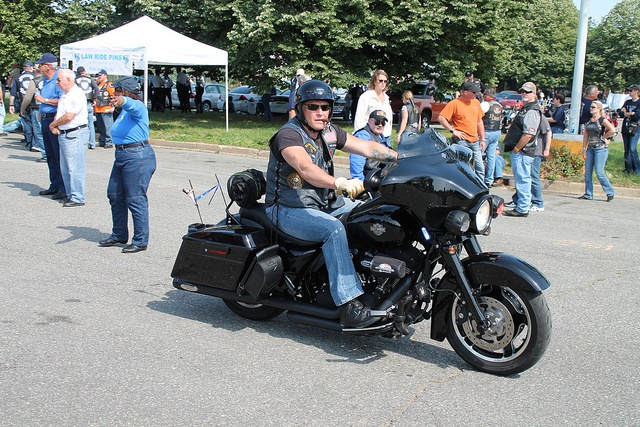Describe the objects in this image and their specific colors. I can see motorcycle in tan, black, gray, and blue tones, people in tan, black, gray, and blue tones, people in tan, black, gray, lightgray, and darkgray tones, people in tan, gray, navy, black, and blue tones, and people in tan, white, lightblue, darkgray, and gray tones in this image. 